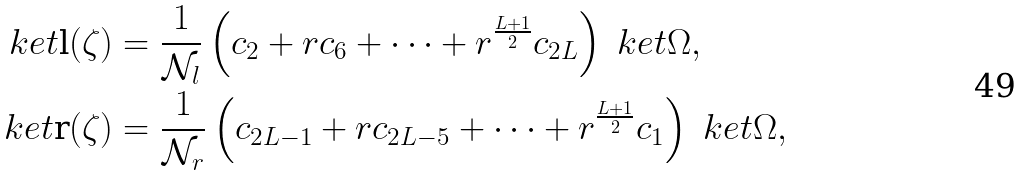<formula> <loc_0><loc_0><loc_500><loc_500>\ k e t { \text {l} ( \zeta ) } & = \frac { 1 } { \mathcal { N } _ { l } } \left ( c _ { 2 } + r c _ { 6 } + \cdots + r ^ { \frac { L + 1 } { 2 } } c _ { 2 L } \right ) \ k e t { \Omega } , \\ \ k e t { \text {r} ( \zeta ) } & = \frac { 1 } { \mathcal { N } _ { r } } \left ( c _ { 2 L - 1 } + r c _ { 2 L - 5 } + \cdots + r ^ { \frac { L + 1 } { 2 } } c _ { 1 } \right ) \ k e t { \Omega } ,</formula> 